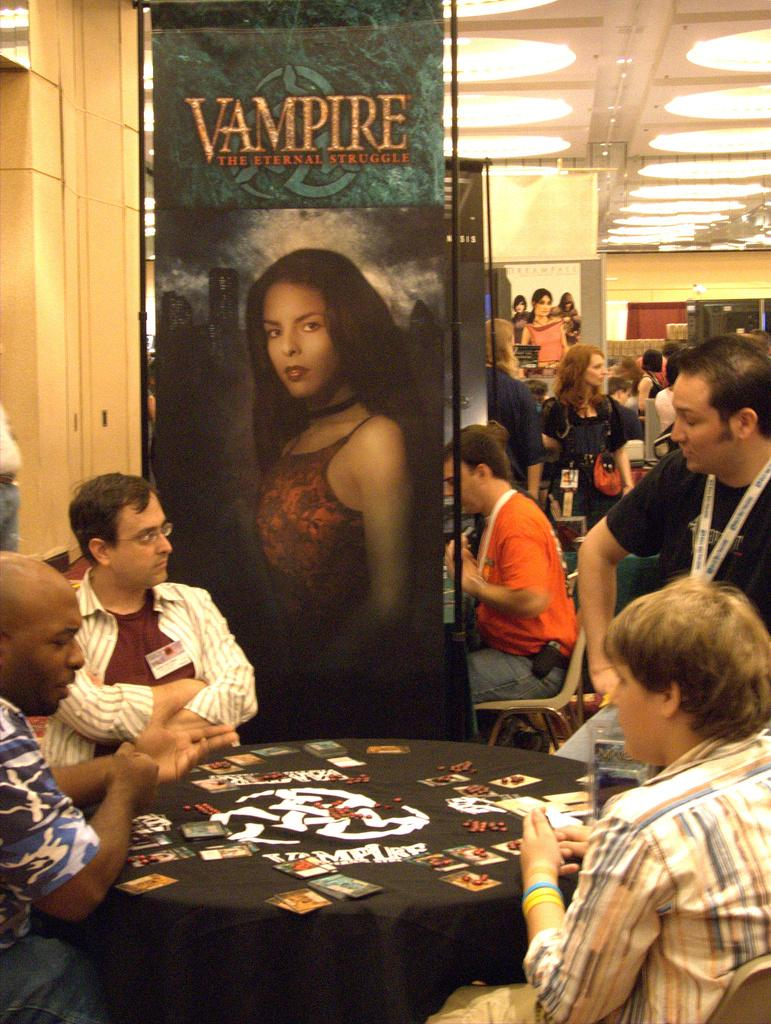What are the people in the image doing? The people are sitting around a table in the image. What objects are on the table? There are cards on the table. Can you describe the background of the image? There are people, banners, the ceiling, and lights visible in the background of the image. What type of stamp can be seen on the cards in the image? There is no stamp visible on the cards in the image. How many matches are being played in the image? The image does not show any matches being played; it only shows people sitting around a table with cards. 